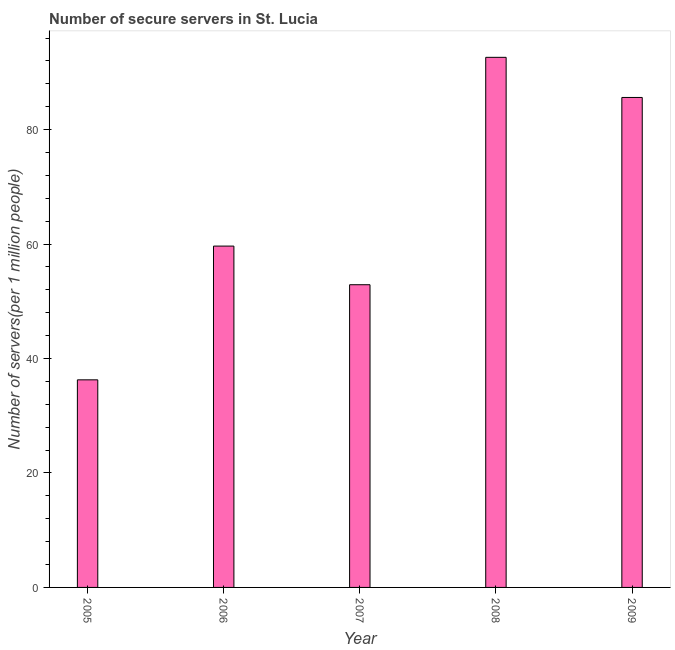What is the title of the graph?
Keep it short and to the point. Number of secure servers in St. Lucia. What is the label or title of the Y-axis?
Offer a terse response. Number of servers(per 1 million people). What is the number of secure internet servers in 2007?
Ensure brevity in your answer.  52.9. Across all years, what is the maximum number of secure internet servers?
Make the answer very short. 92.63. Across all years, what is the minimum number of secure internet servers?
Offer a very short reply. 36.27. In which year was the number of secure internet servers maximum?
Offer a terse response. 2008. What is the sum of the number of secure internet servers?
Keep it short and to the point. 327.06. What is the difference between the number of secure internet servers in 2005 and 2009?
Your answer should be compact. -49.34. What is the average number of secure internet servers per year?
Provide a succinct answer. 65.41. What is the median number of secure internet servers?
Your answer should be compact. 59.65. What is the ratio of the number of secure internet servers in 2007 to that in 2009?
Offer a very short reply. 0.62. Is the number of secure internet servers in 2007 less than that in 2009?
Give a very brief answer. Yes. What is the difference between the highest and the second highest number of secure internet servers?
Keep it short and to the point. 7.01. What is the difference between the highest and the lowest number of secure internet servers?
Keep it short and to the point. 56.36. In how many years, is the number of secure internet servers greater than the average number of secure internet servers taken over all years?
Your answer should be very brief. 2. Are all the bars in the graph horizontal?
Keep it short and to the point. No. What is the difference between two consecutive major ticks on the Y-axis?
Offer a very short reply. 20. Are the values on the major ticks of Y-axis written in scientific E-notation?
Your response must be concise. No. What is the Number of servers(per 1 million people) of 2005?
Make the answer very short. 36.27. What is the Number of servers(per 1 million people) in 2006?
Offer a terse response. 59.65. What is the Number of servers(per 1 million people) in 2007?
Offer a very short reply. 52.9. What is the Number of servers(per 1 million people) of 2008?
Ensure brevity in your answer.  92.63. What is the Number of servers(per 1 million people) of 2009?
Your response must be concise. 85.62. What is the difference between the Number of servers(per 1 million people) in 2005 and 2006?
Your answer should be compact. -23.37. What is the difference between the Number of servers(per 1 million people) in 2005 and 2007?
Provide a succinct answer. -16.62. What is the difference between the Number of servers(per 1 million people) in 2005 and 2008?
Offer a terse response. -56.36. What is the difference between the Number of servers(per 1 million people) in 2005 and 2009?
Offer a very short reply. -49.34. What is the difference between the Number of servers(per 1 million people) in 2006 and 2007?
Give a very brief answer. 6.75. What is the difference between the Number of servers(per 1 million people) in 2006 and 2008?
Your response must be concise. -32.98. What is the difference between the Number of servers(per 1 million people) in 2006 and 2009?
Provide a succinct answer. -25.97. What is the difference between the Number of servers(per 1 million people) in 2007 and 2008?
Ensure brevity in your answer.  -39.73. What is the difference between the Number of servers(per 1 million people) in 2007 and 2009?
Give a very brief answer. -32.72. What is the difference between the Number of servers(per 1 million people) in 2008 and 2009?
Your answer should be very brief. 7.01. What is the ratio of the Number of servers(per 1 million people) in 2005 to that in 2006?
Your answer should be very brief. 0.61. What is the ratio of the Number of servers(per 1 million people) in 2005 to that in 2007?
Offer a terse response. 0.69. What is the ratio of the Number of servers(per 1 million people) in 2005 to that in 2008?
Offer a terse response. 0.39. What is the ratio of the Number of servers(per 1 million people) in 2005 to that in 2009?
Offer a terse response. 0.42. What is the ratio of the Number of servers(per 1 million people) in 2006 to that in 2007?
Make the answer very short. 1.13. What is the ratio of the Number of servers(per 1 million people) in 2006 to that in 2008?
Your response must be concise. 0.64. What is the ratio of the Number of servers(per 1 million people) in 2006 to that in 2009?
Your answer should be compact. 0.7. What is the ratio of the Number of servers(per 1 million people) in 2007 to that in 2008?
Give a very brief answer. 0.57. What is the ratio of the Number of servers(per 1 million people) in 2007 to that in 2009?
Provide a succinct answer. 0.62. What is the ratio of the Number of servers(per 1 million people) in 2008 to that in 2009?
Your answer should be compact. 1.08. 